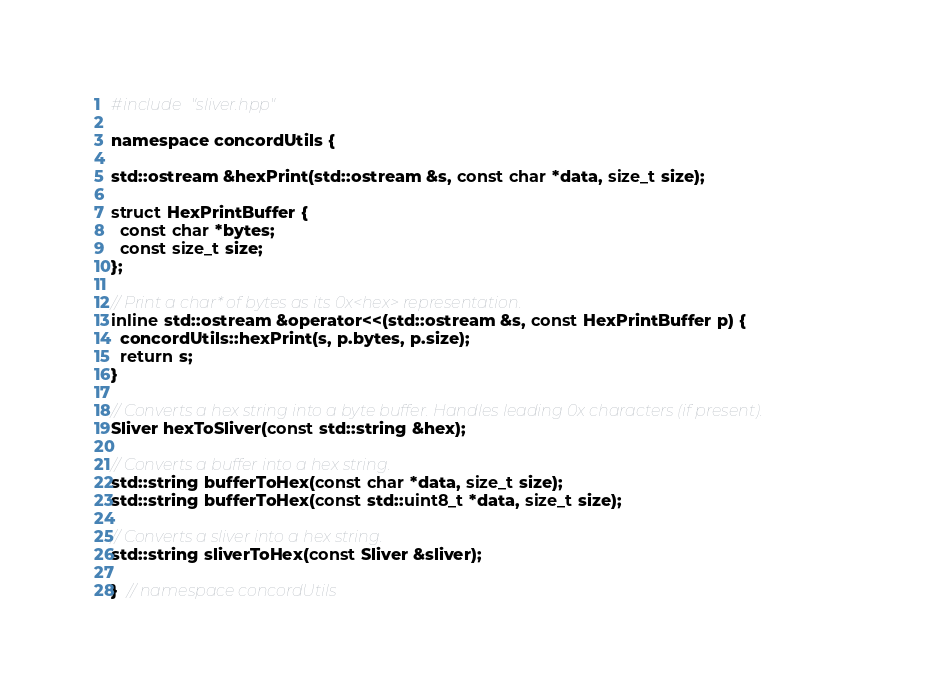<code> <loc_0><loc_0><loc_500><loc_500><_C_>
#include "sliver.hpp"

namespace concordUtils {

std::ostream &hexPrint(std::ostream &s, const char *data, size_t size);

struct HexPrintBuffer {
  const char *bytes;
  const size_t size;
};

// Print a char* of bytes as its 0x<hex> representation.
inline std::ostream &operator<<(std::ostream &s, const HexPrintBuffer p) {
  concordUtils::hexPrint(s, p.bytes, p.size);
  return s;
}

// Converts a hex string into a byte buffer. Handles leading 0x characters (if present).
Sliver hexToSliver(const std::string &hex);

// Converts a buffer into a hex string.
std::string bufferToHex(const char *data, size_t size);
std::string bufferToHex(const std::uint8_t *data, size_t size);

// Converts a sliver into a hex string.
std::string sliverToHex(const Sliver &sliver);

}  // namespace concordUtils
</code> 